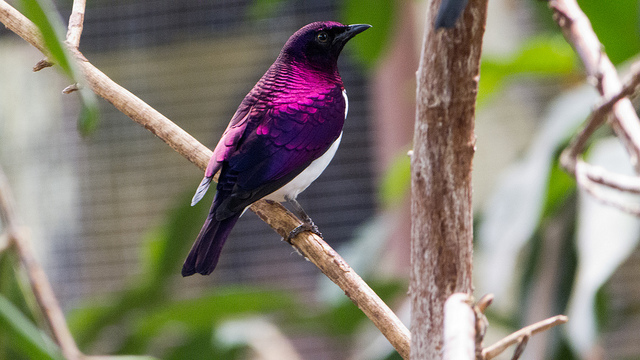Imagine this bird could talk, what do you think it would say? Hello! Aren't my feathers just dazzling? I spend my days flitting from branch to branch, singing melodies and searching for delicious insects and berries. The forest is my home, and there's always something fascinating to discover! What other creatures share its habitat? In the woodlands and savannahs of Sub-Saharan Africa, you might find a diverse array of wildlife sharing the habitat with the Amethyst Starling. This includes small mammals like bushbabies and various species of bats, other bird species such as the African Grey Parrot, and larger animals like antelopes and primates. The region is teeming with life, making it a vibrant ecosystem. 